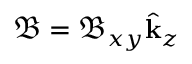Convert formula to latex. <formula><loc_0><loc_0><loc_500><loc_500>\mathfrak { B } = \mathfrak { B } _ { x y } \hat { k } _ { z }</formula> 